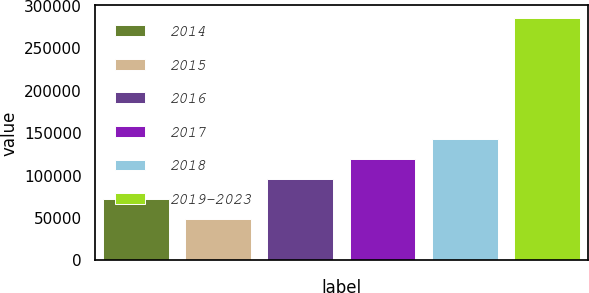<chart> <loc_0><loc_0><loc_500><loc_500><bar_chart><fcel>2014<fcel>2015<fcel>2016<fcel>2017<fcel>2018<fcel>2019-2023<nl><fcel>72282<fcel>48500<fcel>96064<fcel>119846<fcel>143628<fcel>286320<nl></chart> 